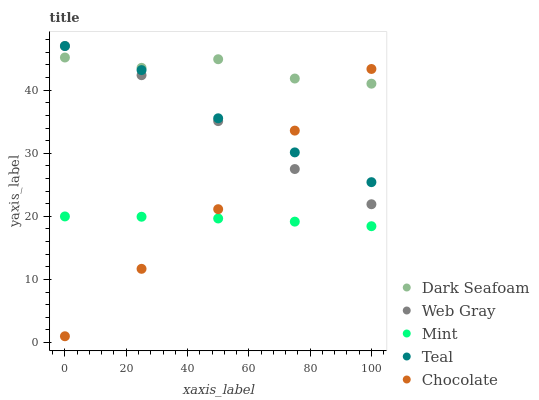Does Mint have the minimum area under the curve?
Answer yes or no. Yes. Does Dark Seafoam have the maximum area under the curve?
Answer yes or no. Yes. Does Web Gray have the minimum area under the curve?
Answer yes or no. No. Does Web Gray have the maximum area under the curve?
Answer yes or no. No. Is Mint the smoothest?
Answer yes or no. Yes. Is Dark Seafoam the roughest?
Answer yes or no. Yes. Is Web Gray the smoothest?
Answer yes or no. No. Is Web Gray the roughest?
Answer yes or no. No. Does Chocolate have the lowest value?
Answer yes or no. Yes. Does Web Gray have the lowest value?
Answer yes or no. No. Does Teal have the highest value?
Answer yes or no. Yes. Does Mint have the highest value?
Answer yes or no. No. Is Mint less than Web Gray?
Answer yes or no. Yes. Is Dark Seafoam greater than Mint?
Answer yes or no. Yes. Does Chocolate intersect Dark Seafoam?
Answer yes or no. Yes. Is Chocolate less than Dark Seafoam?
Answer yes or no. No. Is Chocolate greater than Dark Seafoam?
Answer yes or no. No. Does Mint intersect Web Gray?
Answer yes or no. No. 